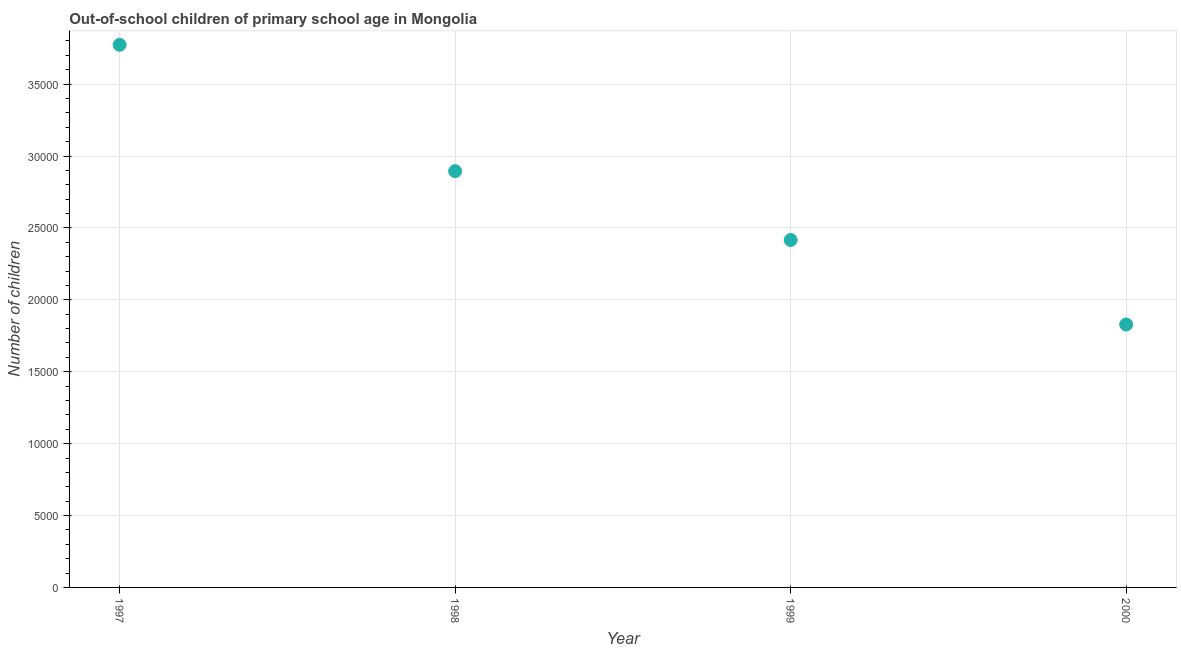What is the number of out-of-school children in 1998?
Your response must be concise. 2.89e+04. Across all years, what is the maximum number of out-of-school children?
Offer a very short reply. 3.77e+04. Across all years, what is the minimum number of out-of-school children?
Your answer should be very brief. 1.83e+04. In which year was the number of out-of-school children maximum?
Keep it short and to the point. 1997. In which year was the number of out-of-school children minimum?
Your response must be concise. 2000. What is the sum of the number of out-of-school children?
Your answer should be very brief. 1.09e+05. What is the difference between the number of out-of-school children in 1999 and 2000?
Your response must be concise. 5876. What is the average number of out-of-school children per year?
Provide a succinct answer. 2.73e+04. What is the median number of out-of-school children?
Provide a succinct answer. 2.66e+04. Do a majority of the years between 2000 and 1998 (inclusive) have number of out-of-school children greater than 35000 ?
Offer a terse response. No. What is the ratio of the number of out-of-school children in 1998 to that in 2000?
Your response must be concise. 1.58. What is the difference between the highest and the second highest number of out-of-school children?
Offer a very short reply. 8788. What is the difference between the highest and the lowest number of out-of-school children?
Your answer should be compact. 1.94e+04. Does the number of out-of-school children monotonically increase over the years?
Your response must be concise. No. How many years are there in the graph?
Provide a succinct answer. 4. Are the values on the major ticks of Y-axis written in scientific E-notation?
Provide a succinct answer. No. Does the graph contain any zero values?
Your answer should be very brief. No. What is the title of the graph?
Make the answer very short. Out-of-school children of primary school age in Mongolia. What is the label or title of the X-axis?
Offer a terse response. Year. What is the label or title of the Y-axis?
Ensure brevity in your answer.  Number of children. What is the Number of children in 1997?
Offer a very short reply. 3.77e+04. What is the Number of children in 1998?
Give a very brief answer. 2.89e+04. What is the Number of children in 1999?
Your response must be concise. 2.42e+04. What is the Number of children in 2000?
Offer a terse response. 1.83e+04. What is the difference between the Number of children in 1997 and 1998?
Provide a short and direct response. 8788. What is the difference between the Number of children in 1997 and 1999?
Your answer should be very brief. 1.36e+04. What is the difference between the Number of children in 1997 and 2000?
Your answer should be compact. 1.94e+04. What is the difference between the Number of children in 1998 and 1999?
Offer a very short reply. 4785. What is the difference between the Number of children in 1998 and 2000?
Provide a succinct answer. 1.07e+04. What is the difference between the Number of children in 1999 and 2000?
Ensure brevity in your answer.  5876. What is the ratio of the Number of children in 1997 to that in 1998?
Give a very brief answer. 1.3. What is the ratio of the Number of children in 1997 to that in 1999?
Provide a succinct answer. 1.56. What is the ratio of the Number of children in 1997 to that in 2000?
Offer a very short reply. 2.06. What is the ratio of the Number of children in 1998 to that in 1999?
Make the answer very short. 1.2. What is the ratio of the Number of children in 1998 to that in 2000?
Your response must be concise. 1.58. What is the ratio of the Number of children in 1999 to that in 2000?
Your answer should be very brief. 1.32. 